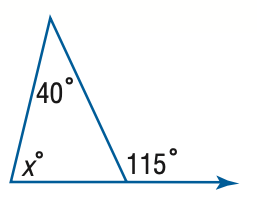Answer the mathemtical geometry problem and directly provide the correct option letter.
Question: Find x.
Choices: A: 40 B: 55 C: 65 D: 75 D 